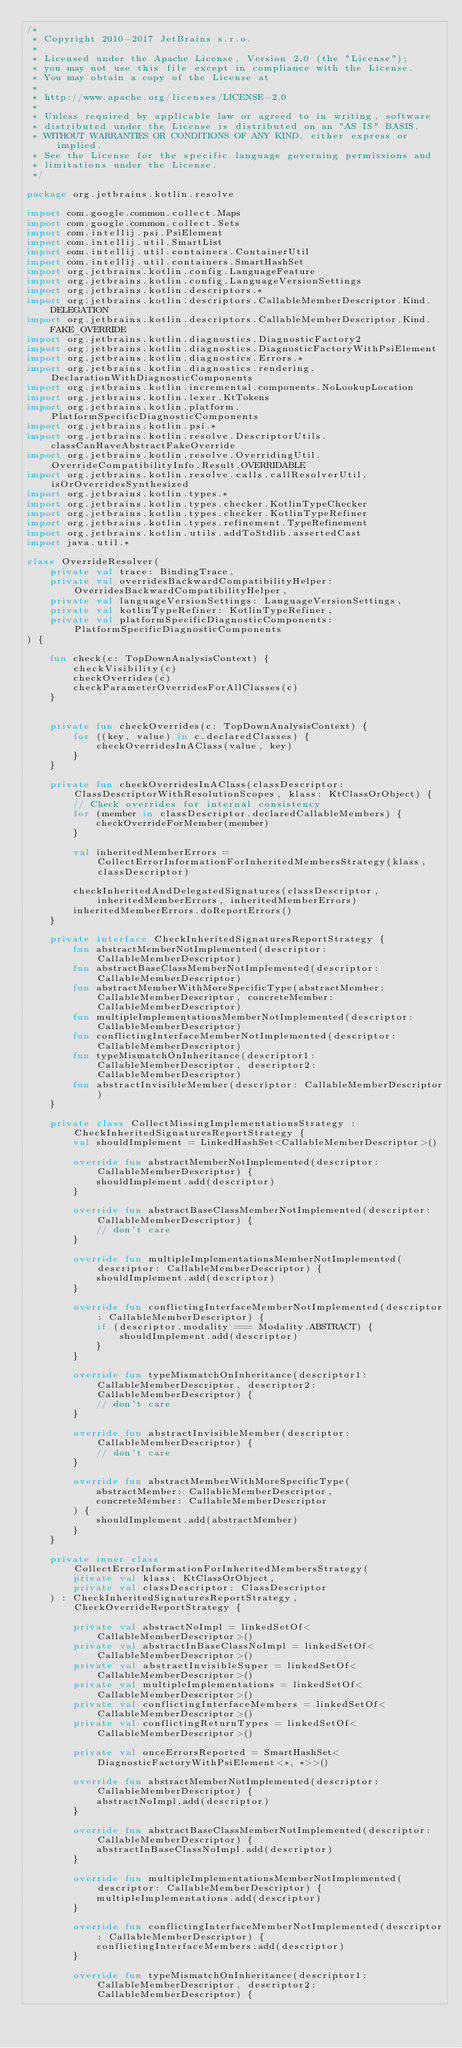Convert code to text. <code><loc_0><loc_0><loc_500><loc_500><_Kotlin_>/*
 * Copyright 2010-2017 JetBrains s.r.o.
 *
 * Licensed under the Apache License, Version 2.0 (the "License");
 * you may not use this file except in compliance with the License.
 * You may obtain a copy of the License at
 *
 * http://www.apache.org/licenses/LICENSE-2.0
 *
 * Unless required by applicable law or agreed to in writing, software
 * distributed under the License is distributed on an "AS IS" BASIS,
 * WITHOUT WARRANTIES OR CONDITIONS OF ANY KIND, either express or implied.
 * See the License for the specific language governing permissions and
 * limitations under the License.
 */

package org.jetbrains.kotlin.resolve

import com.google.common.collect.Maps
import com.google.common.collect.Sets
import com.intellij.psi.PsiElement
import com.intellij.util.SmartList
import com.intellij.util.containers.ContainerUtil
import com.intellij.util.containers.SmartHashSet
import org.jetbrains.kotlin.config.LanguageFeature
import org.jetbrains.kotlin.config.LanguageVersionSettings
import org.jetbrains.kotlin.descriptors.*
import org.jetbrains.kotlin.descriptors.CallableMemberDescriptor.Kind.DELEGATION
import org.jetbrains.kotlin.descriptors.CallableMemberDescriptor.Kind.FAKE_OVERRIDE
import org.jetbrains.kotlin.diagnostics.DiagnosticFactory2
import org.jetbrains.kotlin.diagnostics.DiagnosticFactoryWithPsiElement
import org.jetbrains.kotlin.diagnostics.Errors.*
import org.jetbrains.kotlin.diagnostics.rendering.DeclarationWithDiagnosticComponents
import org.jetbrains.kotlin.incremental.components.NoLookupLocation
import org.jetbrains.kotlin.lexer.KtTokens
import org.jetbrains.kotlin.platform.PlatformSpecificDiagnosticComponents
import org.jetbrains.kotlin.psi.*
import org.jetbrains.kotlin.resolve.DescriptorUtils.classCanHaveAbstractFakeOverride
import org.jetbrains.kotlin.resolve.OverridingUtil.OverrideCompatibilityInfo.Result.OVERRIDABLE
import org.jetbrains.kotlin.resolve.calls.callResolverUtil.isOrOverridesSynthesized
import org.jetbrains.kotlin.types.*
import org.jetbrains.kotlin.types.checker.KotlinTypeChecker
import org.jetbrains.kotlin.types.checker.KotlinTypeRefiner
import org.jetbrains.kotlin.types.refinement.TypeRefinement
import org.jetbrains.kotlin.utils.addToStdlib.assertedCast
import java.util.*

class OverrideResolver(
    private val trace: BindingTrace,
    private val overridesBackwardCompatibilityHelper: OverridesBackwardCompatibilityHelper,
    private val languageVersionSettings: LanguageVersionSettings,
    private val kotlinTypeRefiner: KotlinTypeRefiner,
    private val platformSpecificDiagnosticComponents: PlatformSpecificDiagnosticComponents
) {

    fun check(c: TopDownAnalysisContext) {
        checkVisibility(c)
        checkOverrides(c)
        checkParameterOverridesForAllClasses(c)
    }


    private fun checkOverrides(c: TopDownAnalysisContext) {
        for ((key, value) in c.declaredClasses) {
            checkOverridesInAClass(value, key)
        }
    }

    private fun checkOverridesInAClass(classDescriptor: ClassDescriptorWithResolutionScopes, klass: KtClassOrObject) {
        // Check overrides for internal consistency
        for (member in classDescriptor.declaredCallableMembers) {
            checkOverrideForMember(member)
        }

        val inheritedMemberErrors = CollectErrorInformationForInheritedMembersStrategy(klass, classDescriptor)

        checkInheritedAndDelegatedSignatures(classDescriptor, inheritedMemberErrors, inheritedMemberErrors)
        inheritedMemberErrors.doReportErrors()
    }

    private interface CheckInheritedSignaturesReportStrategy {
        fun abstractMemberNotImplemented(descriptor: CallableMemberDescriptor)
        fun abstractBaseClassMemberNotImplemented(descriptor: CallableMemberDescriptor)
        fun abstractMemberWithMoreSpecificType(abstractMember: CallableMemberDescriptor, concreteMember: CallableMemberDescriptor)
        fun multipleImplementationsMemberNotImplemented(descriptor: CallableMemberDescriptor)
        fun conflictingInterfaceMemberNotImplemented(descriptor: CallableMemberDescriptor)
        fun typeMismatchOnInheritance(descriptor1: CallableMemberDescriptor, descriptor2: CallableMemberDescriptor)
        fun abstractInvisibleMember(descriptor: CallableMemberDescriptor)
    }

    private class CollectMissingImplementationsStrategy : CheckInheritedSignaturesReportStrategy {
        val shouldImplement = LinkedHashSet<CallableMemberDescriptor>()

        override fun abstractMemberNotImplemented(descriptor: CallableMemberDescriptor) {
            shouldImplement.add(descriptor)
        }

        override fun abstractBaseClassMemberNotImplemented(descriptor: CallableMemberDescriptor) {
            // don't care
        }

        override fun multipleImplementationsMemberNotImplemented(descriptor: CallableMemberDescriptor) {
            shouldImplement.add(descriptor)
        }

        override fun conflictingInterfaceMemberNotImplemented(descriptor: CallableMemberDescriptor) {
            if (descriptor.modality === Modality.ABSTRACT) {
                shouldImplement.add(descriptor)
            }
        }

        override fun typeMismatchOnInheritance(descriptor1: CallableMemberDescriptor, descriptor2: CallableMemberDescriptor) {
            // don't care
        }

        override fun abstractInvisibleMember(descriptor: CallableMemberDescriptor) {
            // don't care
        }

        override fun abstractMemberWithMoreSpecificType(
            abstractMember: CallableMemberDescriptor,
            concreteMember: CallableMemberDescriptor
        ) {
            shouldImplement.add(abstractMember)
        }
    }

    private inner class CollectErrorInformationForInheritedMembersStrategy(
        private val klass: KtClassOrObject,
        private val classDescriptor: ClassDescriptor
    ) : CheckInheritedSignaturesReportStrategy, CheckOverrideReportStrategy {

        private val abstractNoImpl = linkedSetOf<CallableMemberDescriptor>()
        private val abstractInBaseClassNoImpl = linkedSetOf<CallableMemberDescriptor>()
        private val abstractInvisibleSuper = linkedSetOf<CallableMemberDescriptor>()
        private val multipleImplementations = linkedSetOf<CallableMemberDescriptor>()
        private val conflictingInterfaceMembers = linkedSetOf<CallableMemberDescriptor>()
        private val conflictingReturnTypes = linkedSetOf<CallableMemberDescriptor>()

        private val onceErrorsReported = SmartHashSet<DiagnosticFactoryWithPsiElement<*, *>>()

        override fun abstractMemberNotImplemented(descriptor: CallableMemberDescriptor) {
            abstractNoImpl.add(descriptor)
        }

        override fun abstractBaseClassMemberNotImplemented(descriptor: CallableMemberDescriptor) {
            abstractInBaseClassNoImpl.add(descriptor)
        }

        override fun multipleImplementationsMemberNotImplemented(descriptor: CallableMemberDescriptor) {
            multipleImplementations.add(descriptor)
        }

        override fun conflictingInterfaceMemberNotImplemented(descriptor: CallableMemberDescriptor) {
            conflictingInterfaceMembers.add(descriptor)
        }

        override fun typeMismatchOnInheritance(descriptor1: CallableMemberDescriptor, descriptor2: CallableMemberDescriptor) {</code> 